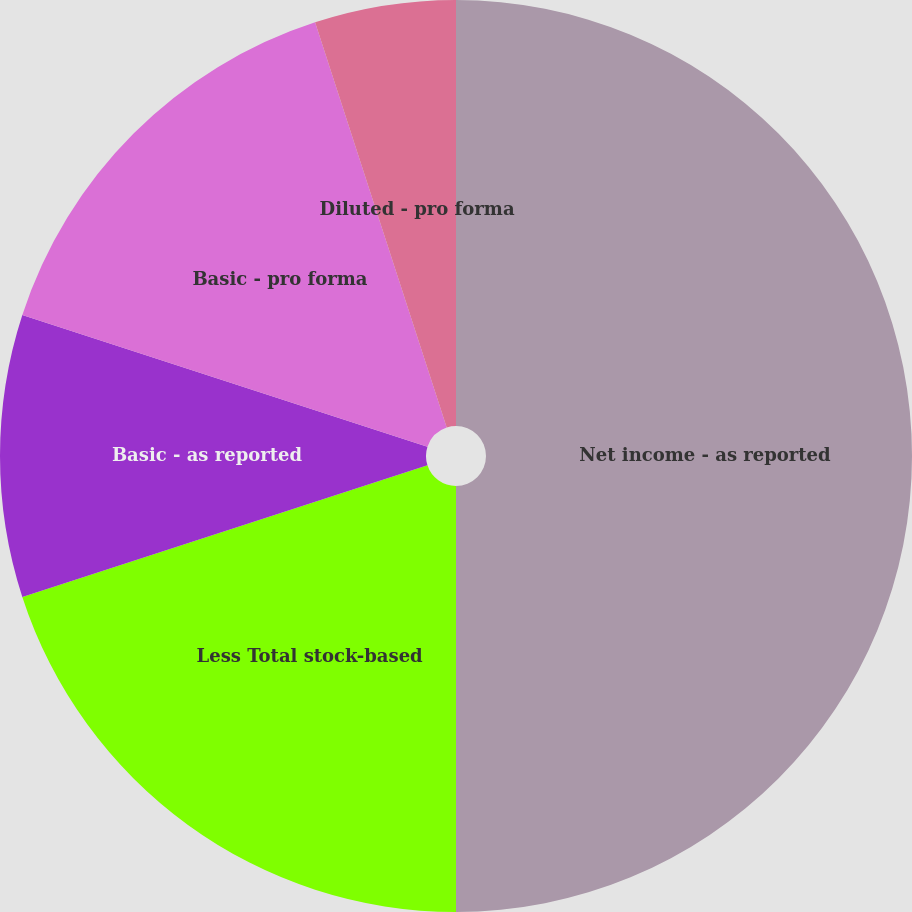<chart> <loc_0><loc_0><loc_500><loc_500><pie_chart><fcel>Net income - as reported<fcel>Less Total stock-based<fcel>Basic - as reported<fcel>Basic - pro forma<fcel>Diluted - asreported<fcel>Diluted - pro forma<nl><fcel>50.0%<fcel>20.0%<fcel>10.0%<fcel>15.0%<fcel>0.0%<fcel>5.0%<nl></chart> 